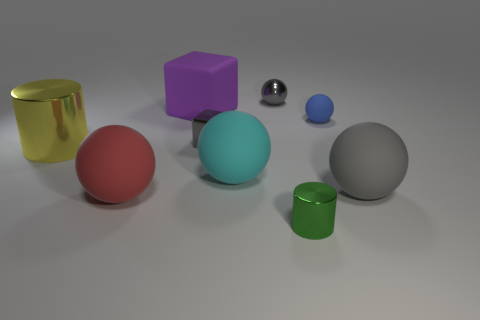Subtract 3 spheres. How many spheres are left? 2 Subtract all tiny gray metal balls. How many balls are left? 4 Subtract all red spheres. How many spheres are left? 4 Subtract all purple balls. Subtract all gray cylinders. How many balls are left? 5 Subtract all cubes. How many objects are left? 7 Add 4 purple matte things. How many purple matte things exist? 5 Subtract 1 yellow cylinders. How many objects are left? 8 Subtract all large red blocks. Subtract all big things. How many objects are left? 4 Add 7 big yellow metallic objects. How many big yellow metallic objects are left? 8 